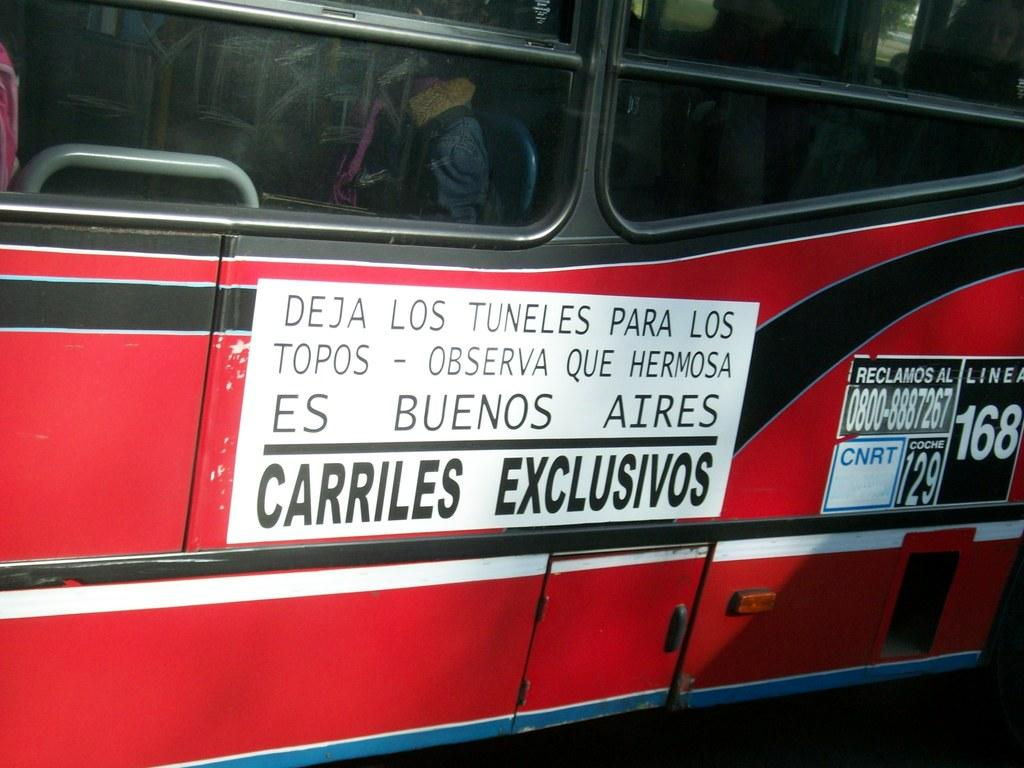What is the main subject of the image? The main subject of the image is a vehicle. Are there any additional features or elements on the vehicle? Yes, the vehicle has posters on it. What type of insect can be seen attacking the vehicle in the image? There is no insect present in the image, nor is there any indication of an attack on the vehicle. 